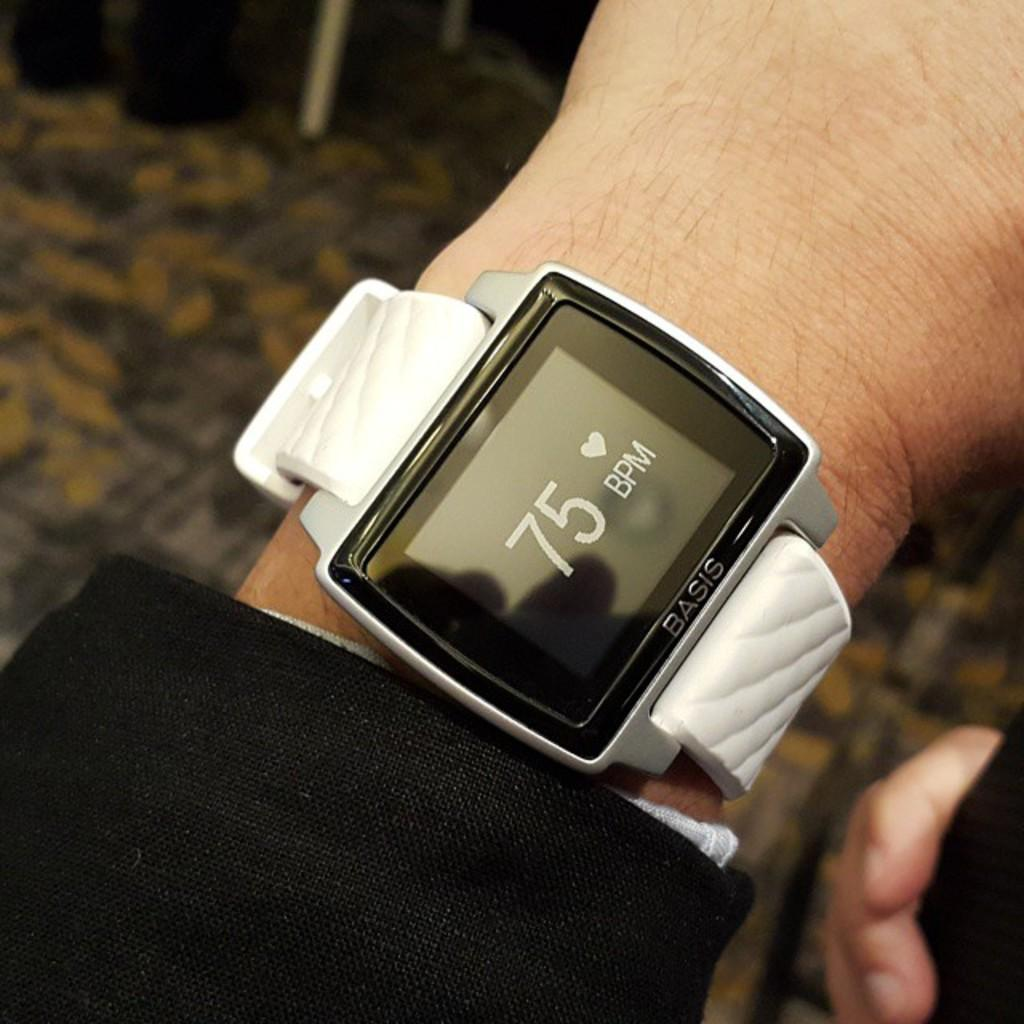What can be seen in the image? There is a person in the image. What is the person wearing on their wrist? The person is wearing a digital watch. What is present on the floor in the background of the image? There is an object on the floor in the background of the image. How clear is the object on the floor in the image? The object on the floor is blurry. What type of vegetable is the person holding in the image? There is no vegetable present in the image; the person is wearing a digital watch. Can you hear the goldfish swimming in the image? There is no goldfish present in the image, so it is not possible to hear any swimming sounds. 